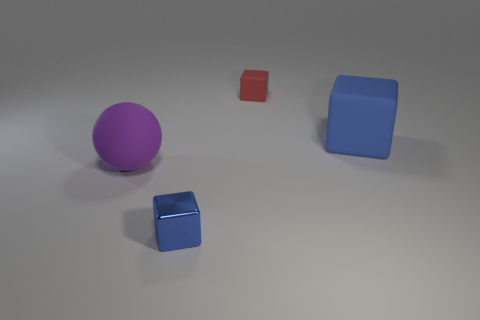The thing that is both behind the big matte sphere and in front of the red object is made of what material?
Your answer should be very brief. Rubber. What number of other objects are there of the same size as the matte ball?
Keep it short and to the point. 1. What is the color of the large cube?
Your answer should be very brief. Blue. There is a tiny object that is behind the big sphere; is it the same color as the large rubber cube that is to the right of the big purple rubber sphere?
Ensure brevity in your answer.  No. How big is the red rubber object?
Provide a short and direct response. Small. What is the size of the blue thing behind the purple object?
Make the answer very short. Large. There is a object that is both behind the small shiny cube and on the left side of the red thing; what is its shape?
Make the answer very short. Sphere. What number of other things are the same shape as the big blue object?
Your response must be concise. 2. What color is the cube that is the same size as the purple object?
Offer a very short reply. Blue. How many things are either big metal spheres or rubber objects?
Provide a short and direct response. 3. 